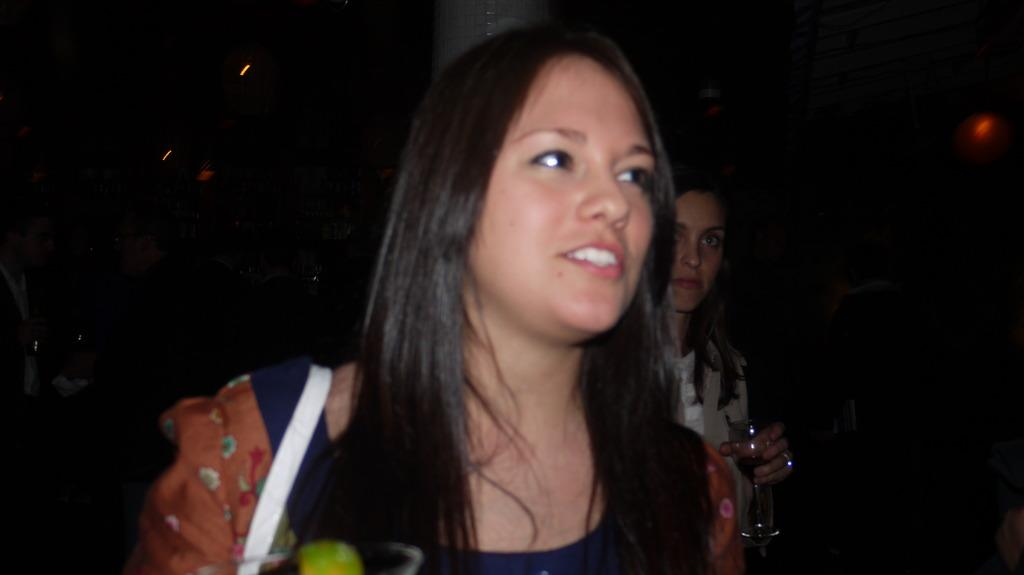What is the person wearing in the image? The person is wearing a different color dress in the image. What is the other person holding in the image? The other person is holding a glass in the image. What color is the background of the image? The background of the image is black. What type of error can be seen on the person's chin in the image? There is no error visible on anyone's chin in the image. How hot is the glass being held by the person in the image? The temperature of the glass is not mentioned in the image, so it cannot be determined. 